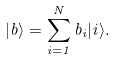Convert formula to latex. <formula><loc_0><loc_0><loc_500><loc_500>| b \rangle = \sum _ { i = 1 } ^ { N } b _ { i } | i \rangle .</formula> 